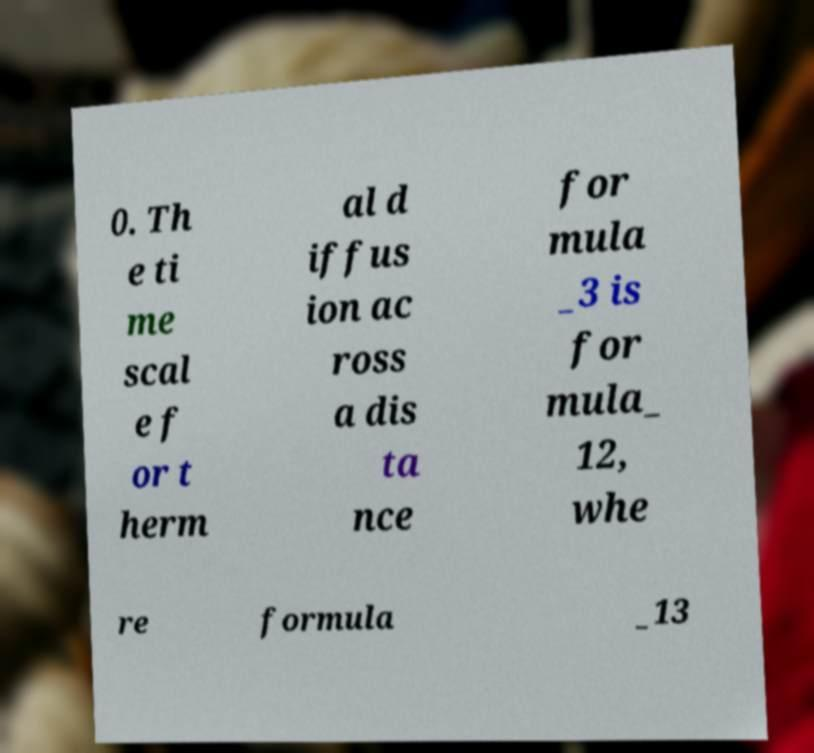I need the written content from this picture converted into text. Can you do that? 0. Th e ti me scal e f or t herm al d iffus ion ac ross a dis ta nce for mula _3 is for mula_ 12, whe re formula _13 